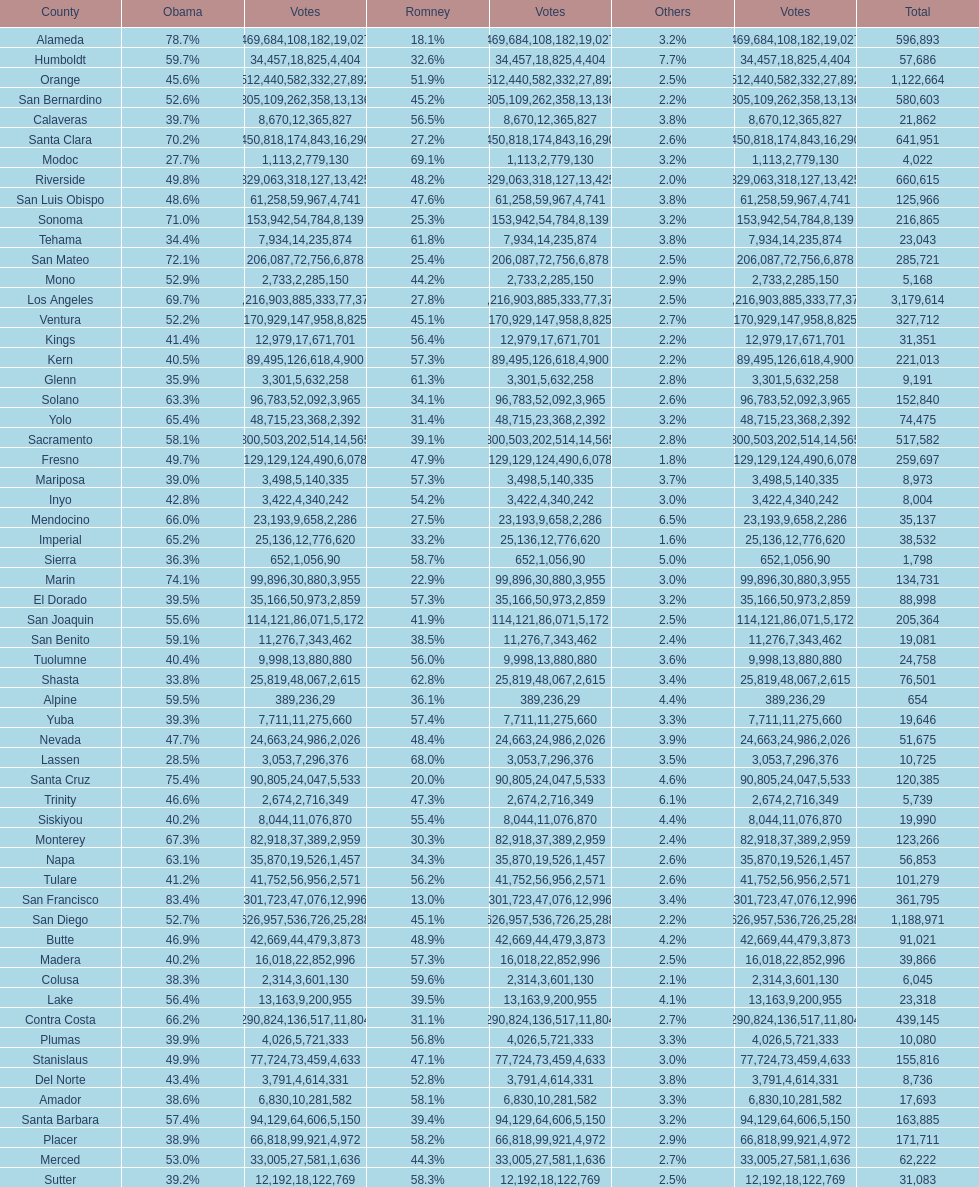Which county comes just prior to del norte on the list? Contra Costa. 